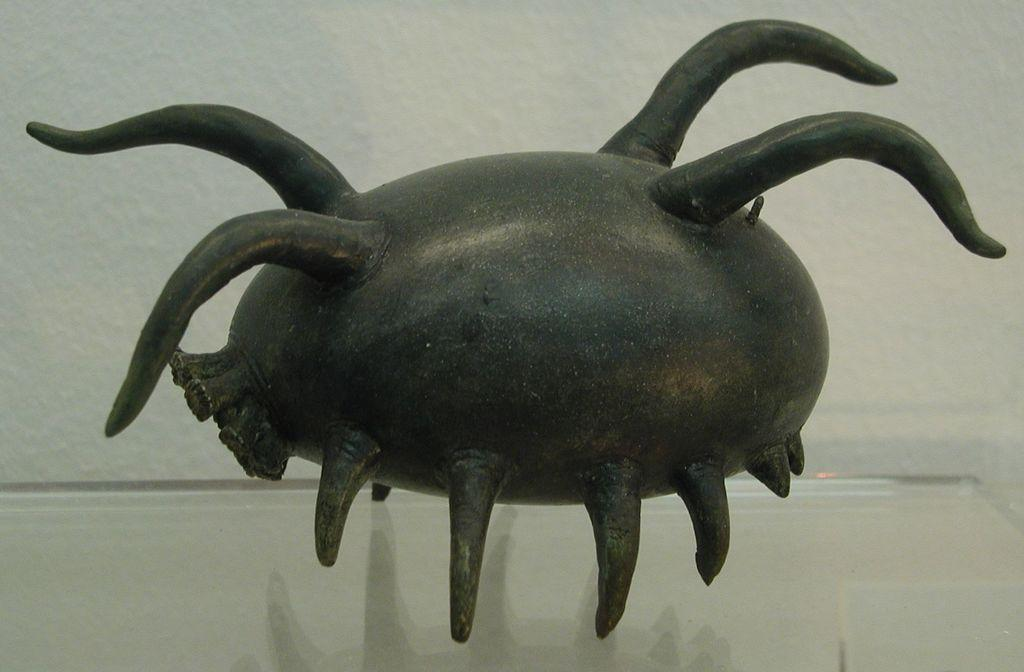What type of artwork is featured in the image? There is a metal sculpture in the image. What object is located at the bottom of the image? There is a glass at the bottom of the image. What structure can be seen at the back of the image? There is a wall at the back of the image. What type of roof is visible on the pig in the image? There is no pig present in the image, and therefore no roof can be observed. What type of store is featured in the image? There is no store present in the image; it features a metal sculpture, a glass, and a wall. 